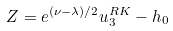Convert formula to latex. <formula><loc_0><loc_0><loc_500><loc_500>Z = e ^ { ( \nu - \lambda ) / 2 } u _ { 3 } ^ { R K } - h _ { 0 }</formula> 